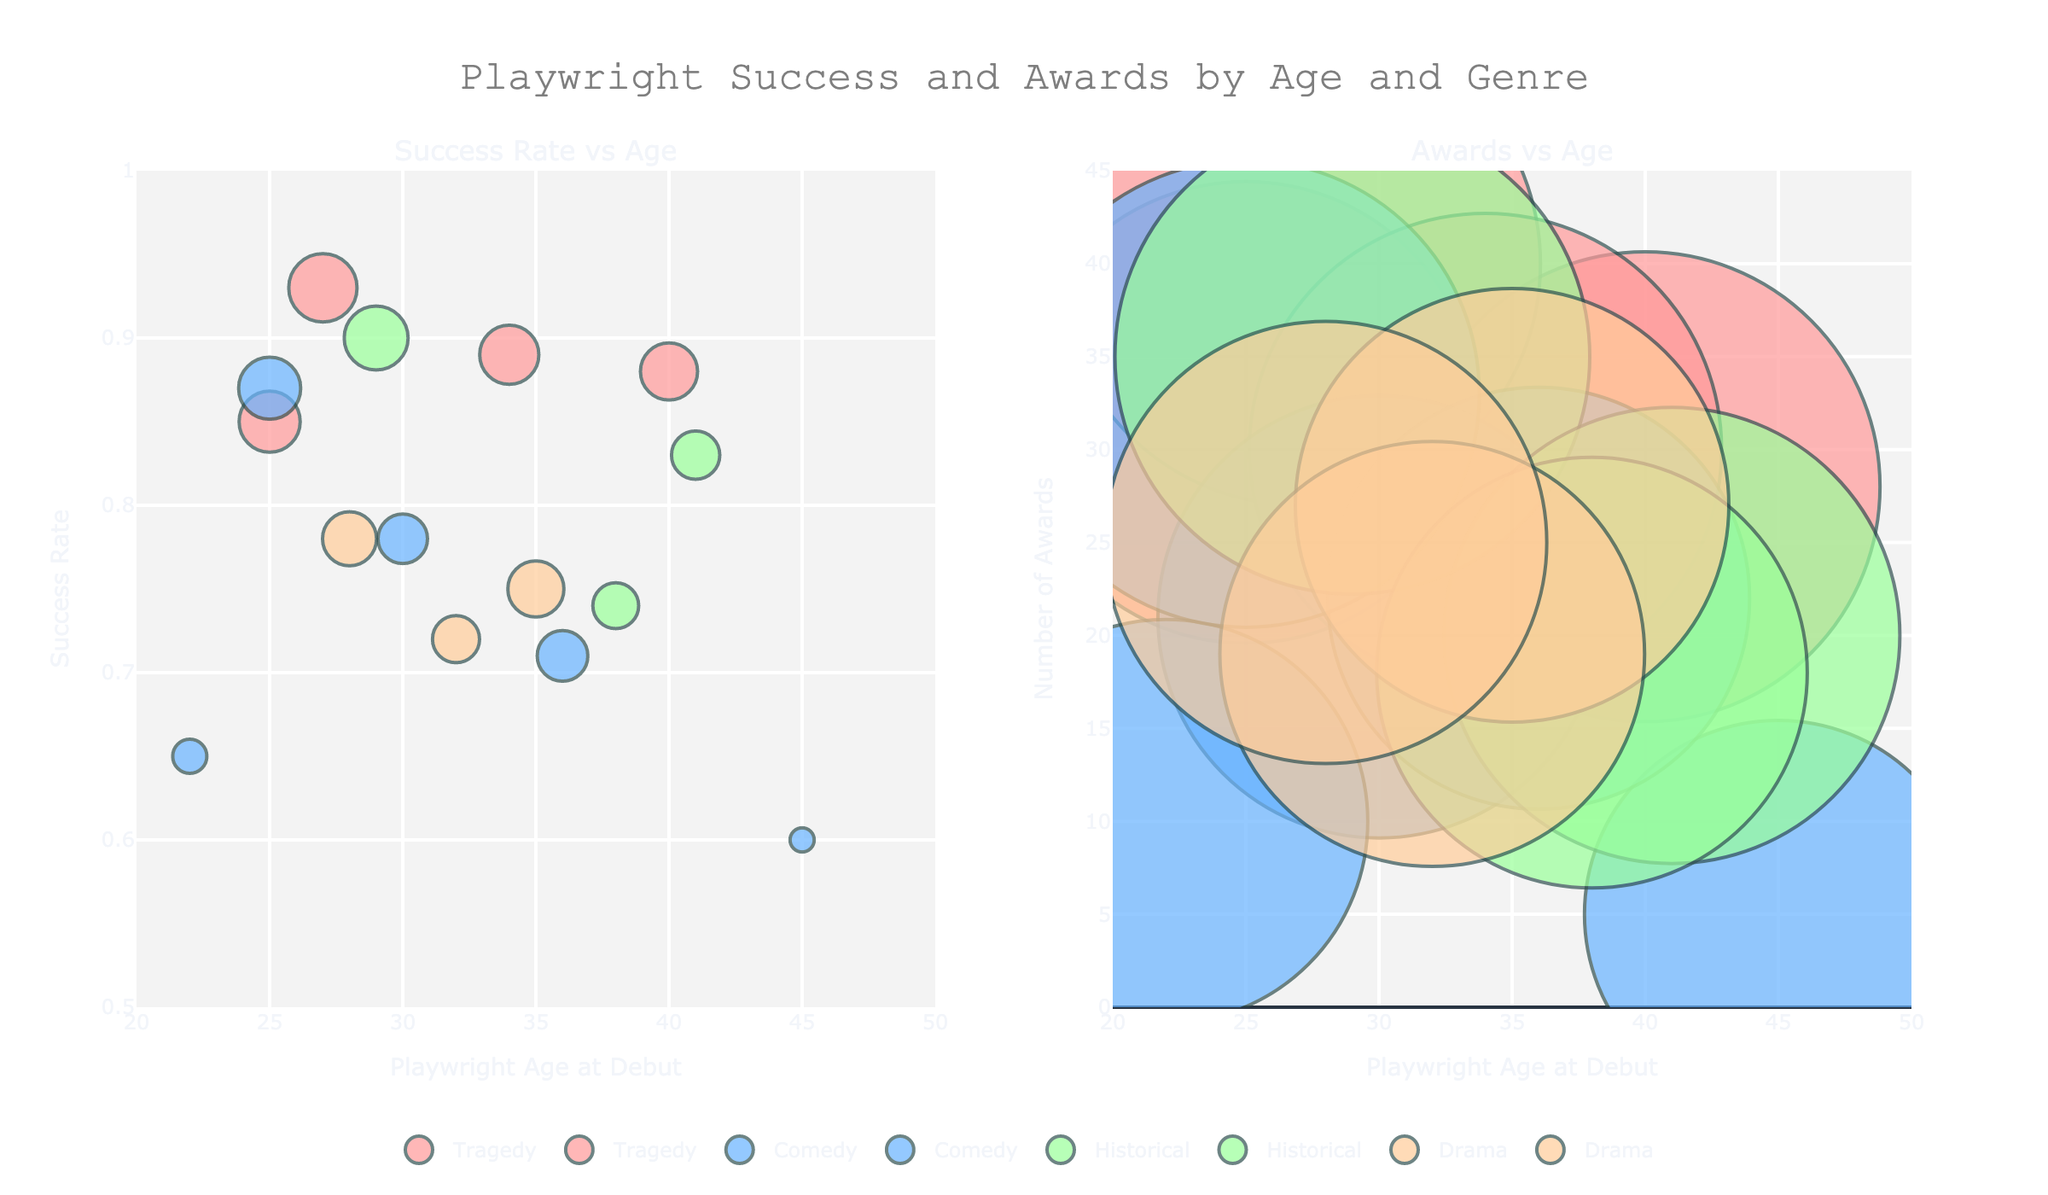What is the title of the figure? The title is located at the top center of the figure, which provides the overall context for what the visualizations are depicting.
Answer: Playwright Success and Awards by Age and Genre What does the x-axis represent in the left subplot? The x-axis in the left subplot is labeled "Playwright Age at Debut," indicating the age at which each playwright debuted.
Answer: Playwright Age at Debut Which genre has the playwright with the highest number of awards? By looking at the size of the bubbles representing the number of awards in the left subplot, we see the largest bubble. This bubble represents the playwright from the Tragedy genre (Sophocles) with 40 awards.
Answer: Tragedy How many genres are represented in the figures? By examining the different colors in the subplots and the legend at the bottom center, we can count the distinct genres included. The figure shows Tragedy, Comedy, Historical, and Drama.
Answer: 4 What genre is represented by the green bubbles in the subplots? According to the color mapping in the legend, green bubbles represent the Historical genre.
Answer: Historical What is the success rate of the youngest playwright who debuted in the Drama genre? When checking the left subplot, find the youngest playwright in the Drama genre by looking at the x-axis. August Strindberg, who debuted at age 28, had a success rate of 0.78, as indicated by the bubble at (28, 0.78).
Answer: 0.78 What is the range of ages for playwrights in the Comedy genre according to the figure? Look at the ages along the x-axes of bubbles colored blue (indicating Comedy), noting the minimum and maximum ages. The ages range from 22 (Noel Coward) to 45 (Nicolai Gogol).
Answer: 22 to 45 Which subplot shows a correlation between Playwright Age at Debut and Number of Awards? The subplot on the right, titled "Awards vs Age," visually represents the relationship between these two variables.
Answer: Right subplot From the "Success Rate vs Age" subplot, what is the success rate of the playwright who debuted at age 40 in the Tragedy genre? Locate the bubble at age 40 on the x-axis in the left subplot within the Tragedy genre. The success rate for Arthur Miller, who debuted at age 40, is 0.88.
Answer: 0.88 Which playwrights debuted at age 30, and how do their success rates compare? By examining the x-axis in the left subplot for age 30, we find that Oscar Wilde (Comedy) has a success rate of 0.78, while no other playwrights debuted at this age. Therefore, comparison isn't necessary for other playwrights.
Answer: Oscar Wilde has a success rate of 0.78 